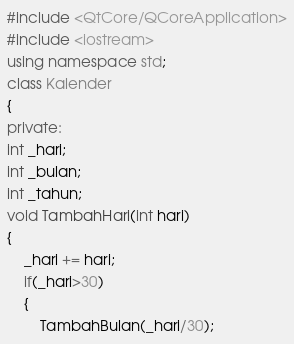<code> <loc_0><loc_0><loc_500><loc_500><_C++_>#include <QtCore/QCoreApplication>
#include <iostream>
using namespace std;
class Kalender
{
private:
int _hari;
int _bulan;
int _tahun;
void TambahHari(int hari)
{
    _hari += hari;
    if(_hari>30)
    {
        TambahBulan(_hari/30);</code> 